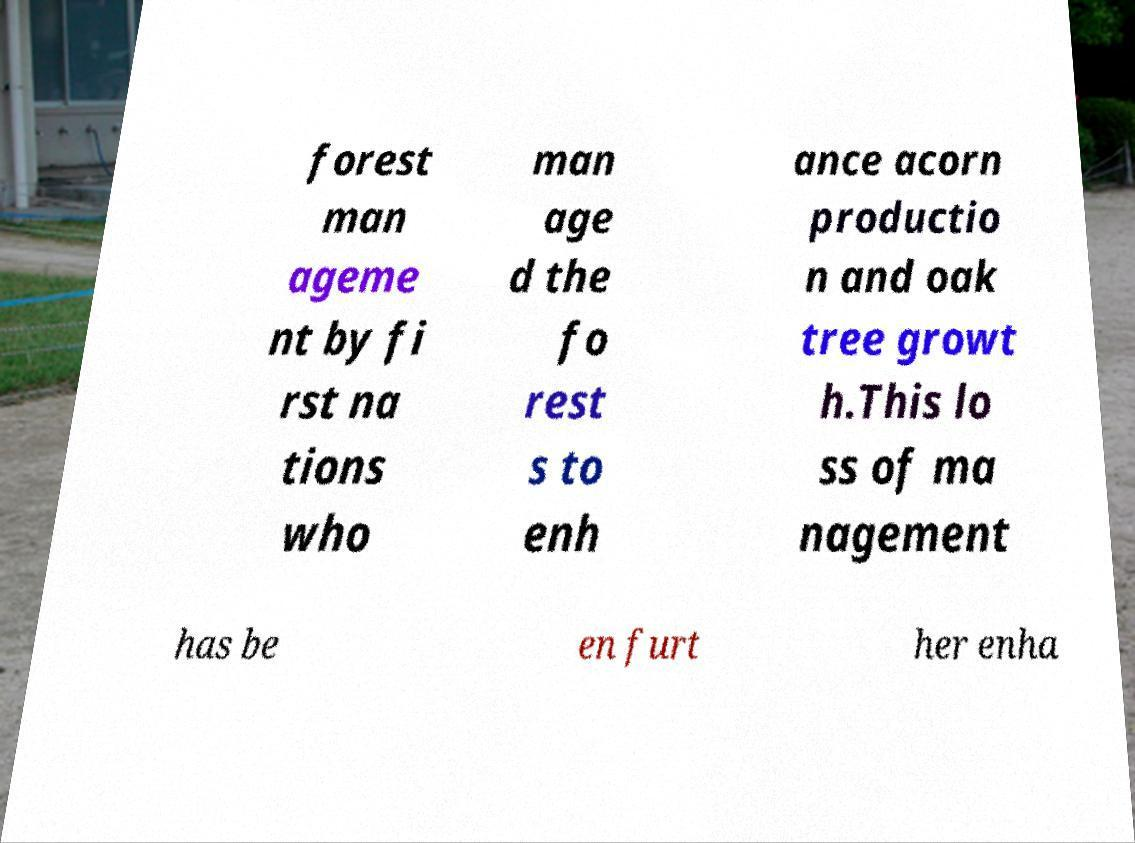There's text embedded in this image that I need extracted. Can you transcribe it verbatim? forest man ageme nt by fi rst na tions who man age d the fo rest s to enh ance acorn productio n and oak tree growt h.This lo ss of ma nagement has be en furt her enha 